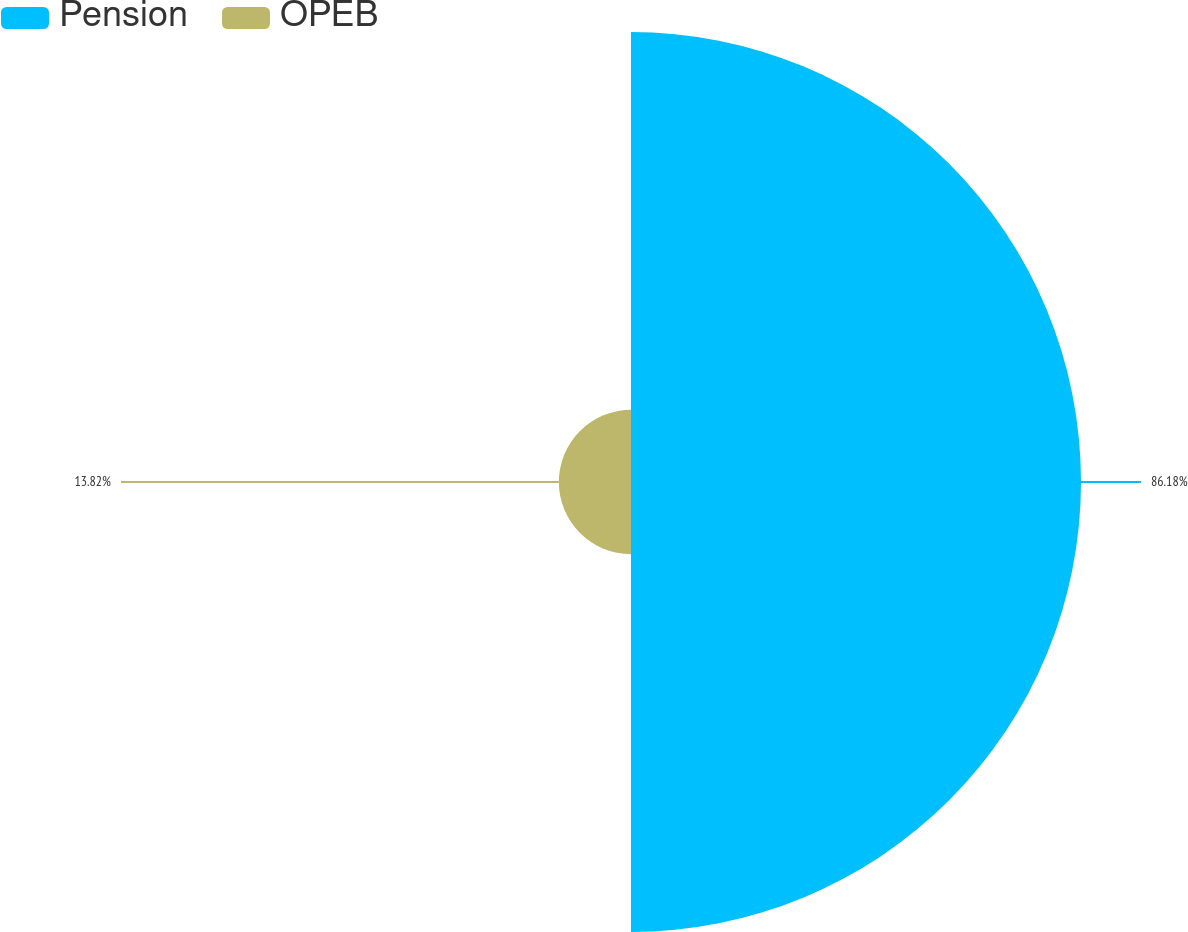Convert chart to OTSL. <chart><loc_0><loc_0><loc_500><loc_500><pie_chart><fcel>Pension<fcel>OPEB<nl><fcel>86.18%<fcel>13.82%<nl></chart> 